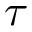Convert formula to latex. <formula><loc_0><loc_0><loc_500><loc_500>\tau</formula> 